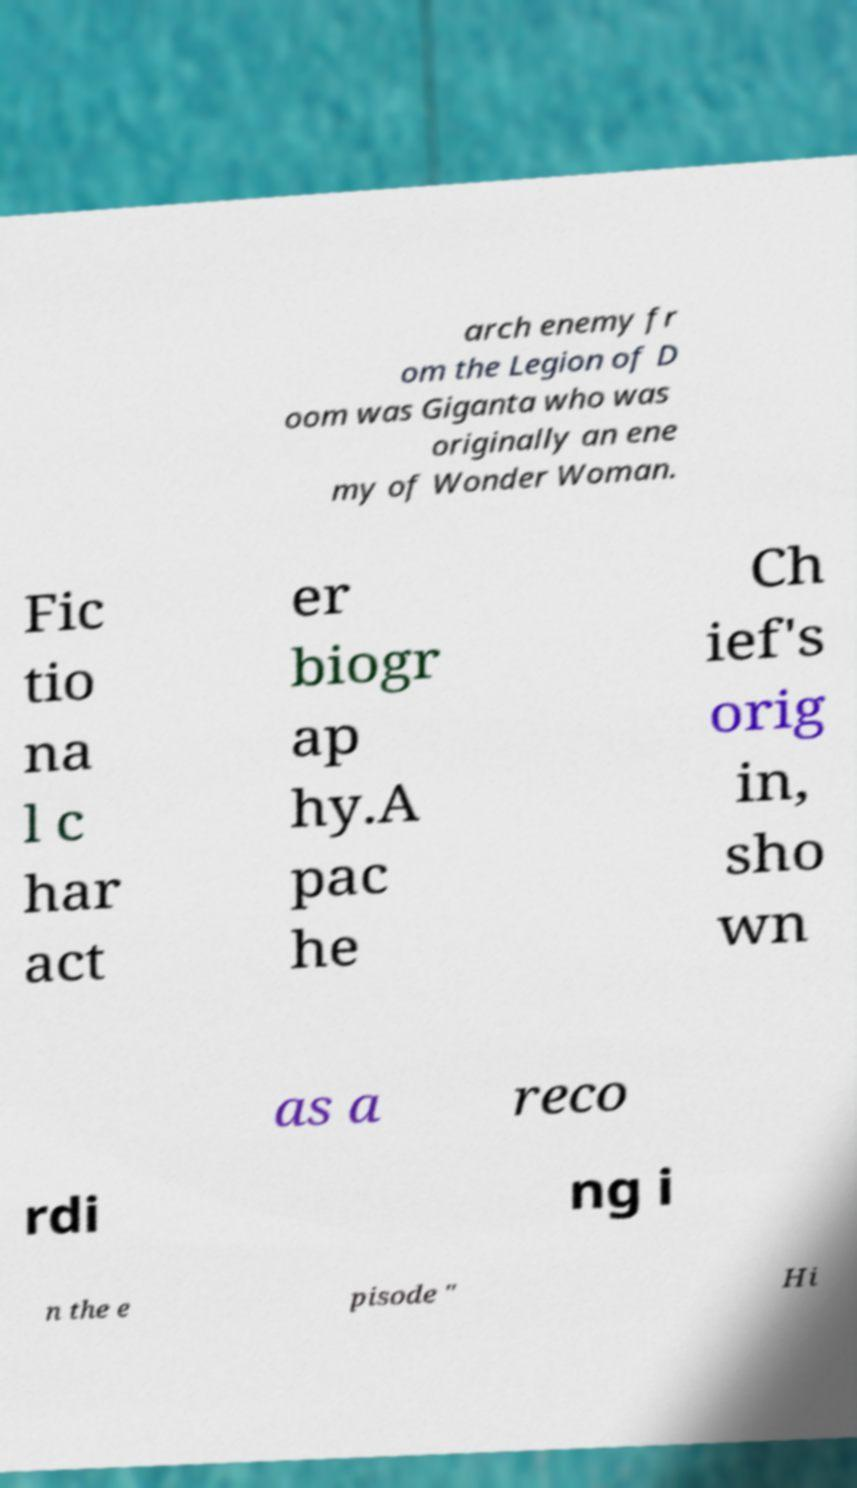What messages or text are displayed in this image? I need them in a readable, typed format. arch enemy fr om the Legion of D oom was Giganta who was originally an ene my of Wonder Woman. Fic tio na l c har act er biogr ap hy.A pac he Ch ief's orig in, sho wn as a reco rdi ng i n the e pisode " Hi 